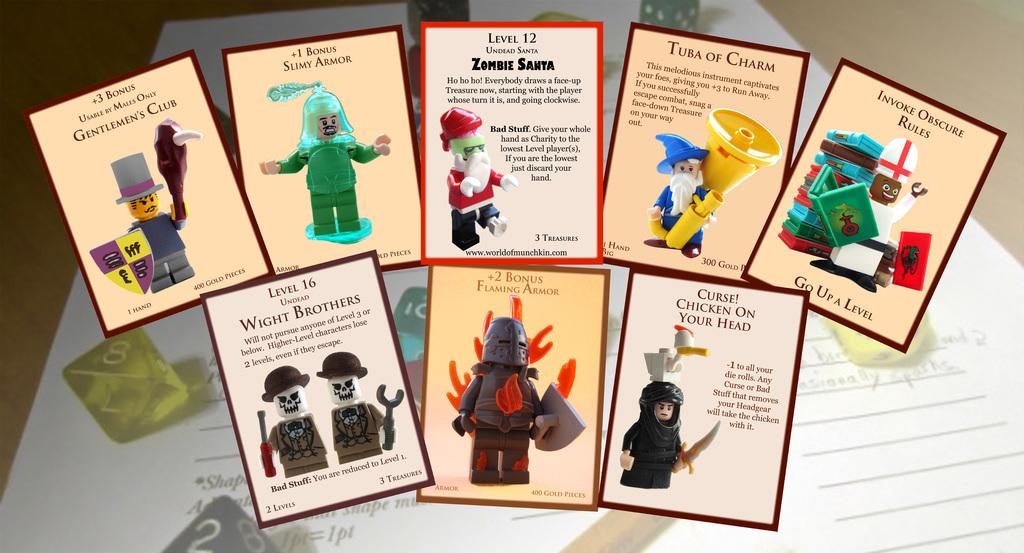<image>
Share a concise interpretation of the image provided. 8 different cards on a table and one of them talks about Zombie Santa. 